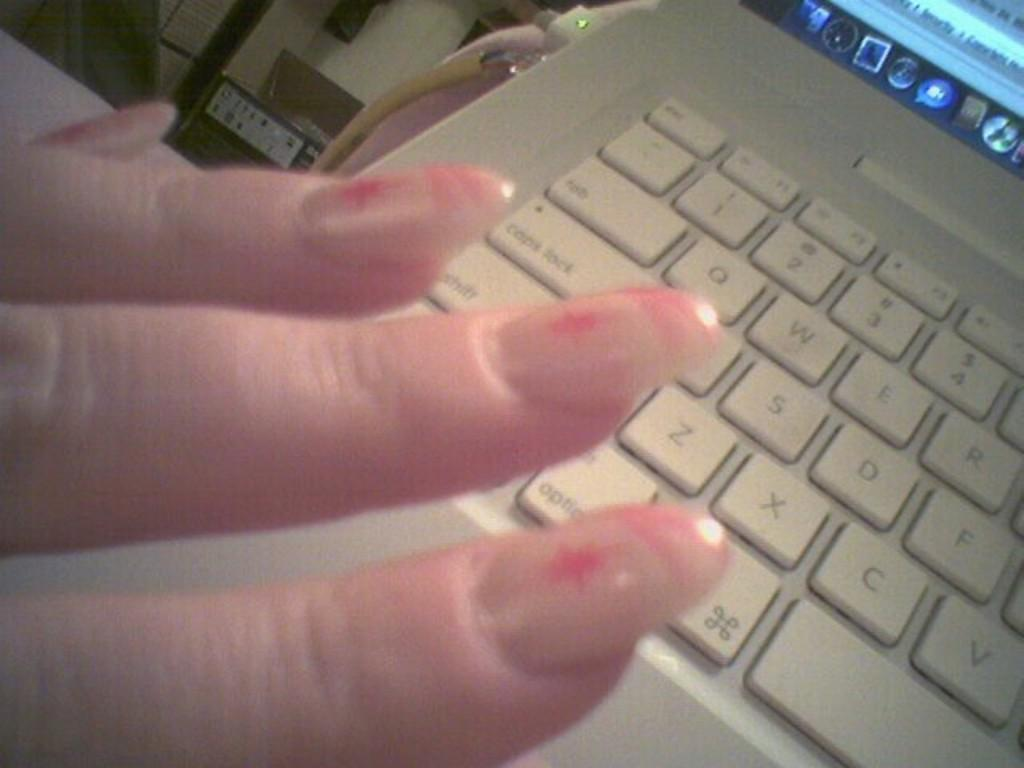<image>
Share a concise interpretation of the image provided. Woman showing freshly painted finger nails with a QWERTY type key board in the background. 